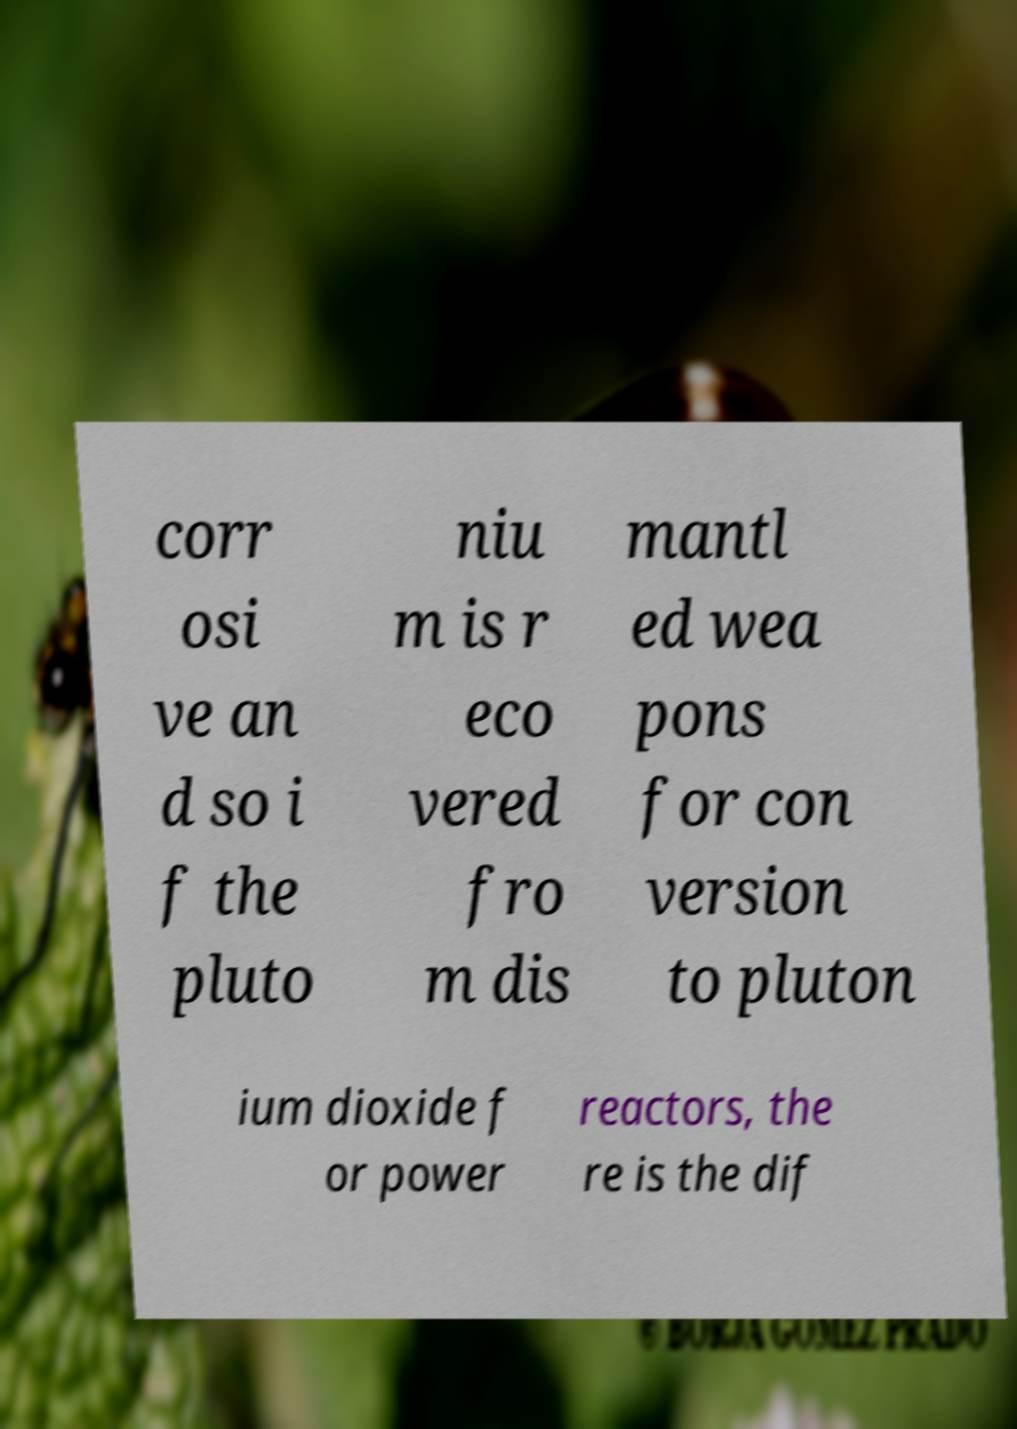I need the written content from this picture converted into text. Can you do that? corr osi ve an d so i f the pluto niu m is r eco vered fro m dis mantl ed wea pons for con version to pluton ium dioxide f or power reactors, the re is the dif 